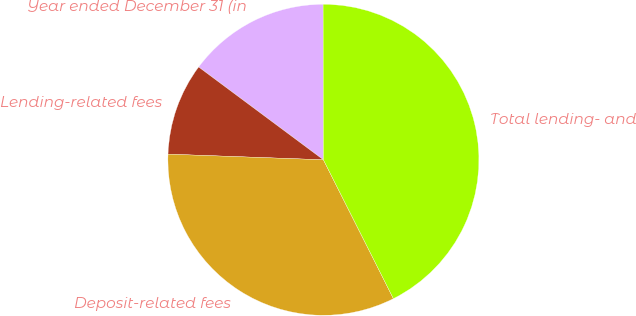Convert chart to OTSL. <chart><loc_0><loc_0><loc_500><loc_500><pie_chart><fcel>Year ended December 31 (in<fcel>Lending-related fees<fcel>Deposit-related fees<fcel>Total lending- and<nl><fcel>14.79%<fcel>9.6%<fcel>33.01%<fcel>42.6%<nl></chart> 